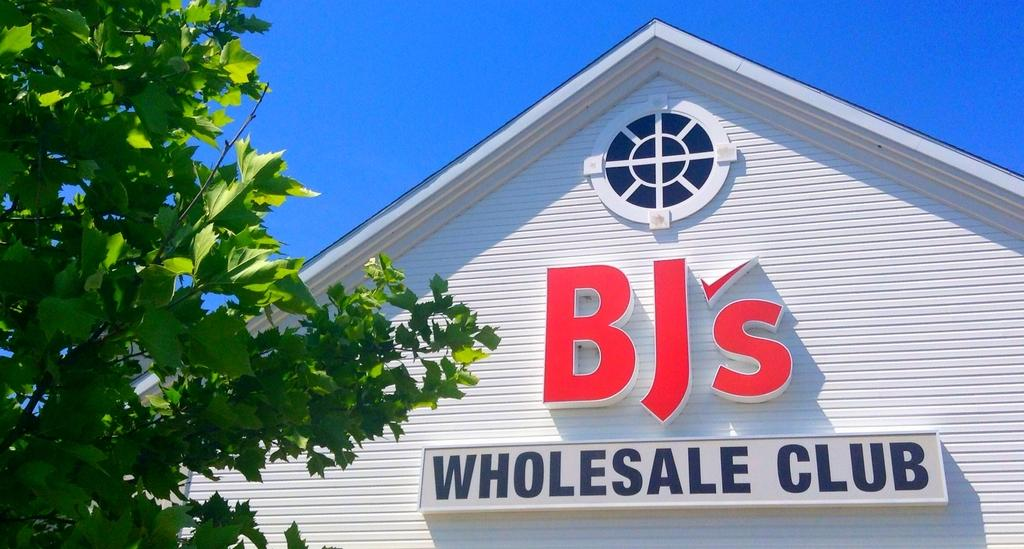<image>
Summarize the visual content of the image. A tree is next to the side of a building which has a round window and lettering that reads BJ's Wholesale Club. 